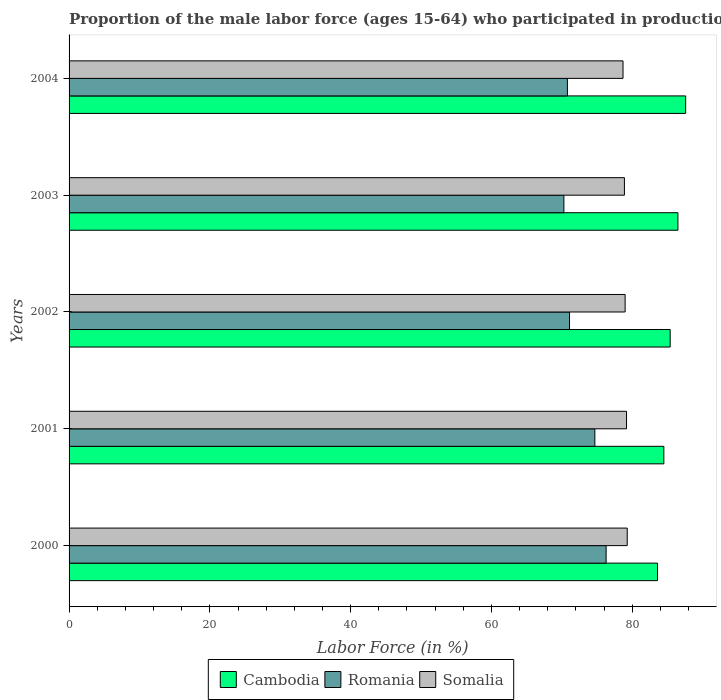How many different coloured bars are there?
Keep it short and to the point. 3. How many groups of bars are there?
Provide a succinct answer. 5. Are the number of bars per tick equal to the number of legend labels?
Ensure brevity in your answer.  Yes. Are the number of bars on each tick of the Y-axis equal?
Make the answer very short. Yes. How many bars are there on the 2nd tick from the top?
Keep it short and to the point. 3. How many bars are there on the 2nd tick from the bottom?
Offer a very short reply. 3. What is the label of the 1st group of bars from the top?
Provide a short and direct response. 2004. What is the proportion of the male labor force who participated in production in Romania in 2000?
Your response must be concise. 76.3. Across all years, what is the maximum proportion of the male labor force who participated in production in Cambodia?
Offer a terse response. 87.6. Across all years, what is the minimum proportion of the male labor force who participated in production in Romania?
Provide a short and direct response. 70.3. In which year was the proportion of the male labor force who participated in production in Somalia maximum?
Ensure brevity in your answer.  2000. In which year was the proportion of the male labor force who participated in production in Romania minimum?
Your answer should be compact. 2003. What is the total proportion of the male labor force who participated in production in Somalia in the graph?
Your answer should be very brief. 395.1. What is the difference between the proportion of the male labor force who participated in production in Romania in 2003 and that in 2004?
Offer a very short reply. -0.5. What is the difference between the proportion of the male labor force who participated in production in Somalia in 2000 and the proportion of the male labor force who participated in production in Cambodia in 2002?
Your answer should be compact. -6.1. What is the average proportion of the male labor force who participated in production in Romania per year?
Your answer should be very brief. 72.64. In the year 2003, what is the difference between the proportion of the male labor force who participated in production in Cambodia and proportion of the male labor force who participated in production in Somalia?
Your answer should be compact. 7.6. In how many years, is the proportion of the male labor force who participated in production in Romania greater than 60 %?
Make the answer very short. 5. What is the ratio of the proportion of the male labor force who participated in production in Cambodia in 2000 to that in 2002?
Provide a succinct answer. 0.98. Is the difference between the proportion of the male labor force who participated in production in Cambodia in 2002 and 2004 greater than the difference between the proportion of the male labor force who participated in production in Somalia in 2002 and 2004?
Your answer should be very brief. No. What is the difference between the highest and the second highest proportion of the male labor force who participated in production in Romania?
Offer a very short reply. 1.6. What is the difference between the highest and the lowest proportion of the male labor force who participated in production in Somalia?
Offer a very short reply. 0.6. Is the sum of the proportion of the male labor force who participated in production in Romania in 2000 and 2003 greater than the maximum proportion of the male labor force who participated in production in Somalia across all years?
Ensure brevity in your answer.  Yes. What does the 2nd bar from the top in 2002 represents?
Your answer should be compact. Romania. What does the 2nd bar from the bottom in 2003 represents?
Ensure brevity in your answer.  Romania. How many bars are there?
Offer a very short reply. 15. How many years are there in the graph?
Your response must be concise. 5. What is the difference between two consecutive major ticks on the X-axis?
Offer a very short reply. 20. Does the graph contain any zero values?
Provide a succinct answer. No. Does the graph contain grids?
Ensure brevity in your answer.  No. How are the legend labels stacked?
Your response must be concise. Horizontal. What is the title of the graph?
Your answer should be compact. Proportion of the male labor force (ages 15-64) who participated in production. Does "High income: OECD" appear as one of the legend labels in the graph?
Your answer should be very brief. No. What is the Labor Force (in %) of Cambodia in 2000?
Provide a succinct answer. 83.6. What is the Labor Force (in %) in Romania in 2000?
Make the answer very short. 76.3. What is the Labor Force (in %) of Somalia in 2000?
Ensure brevity in your answer.  79.3. What is the Labor Force (in %) of Cambodia in 2001?
Your response must be concise. 84.5. What is the Labor Force (in %) in Romania in 2001?
Your answer should be very brief. 74.7. What is the Labor Force (in %) in Somalia in 2001?
Offer a terse response. 79.2. What is the Labor Force (in %) in Cambodia in 2002?
Offer a terse response. 85.4. What is the Labor Force (in %) of Romania in 2002?
Give a very brief answer. 71.1. What is the Labor Force (in %) of Somalia in 2002?
Your answer should be compact. 79. What is the Labor Force (in %) in Cambodia in 2003?
Give a very brief answer. 86.5. What is the Labor Force (in %) in Romania in 2003?
Give a very brief answer. 70.3. What is the Labor Force (in %) in Somalia in 2003?
Your response must be concise. 78.9. What is the Labor Force (in %) in Cambodia in 2004?
Your answer should be compact. 87.6. What is the Labor Force (in %) in Romania in 2004?
Ensure brevity in your answer.  70.8. What is the Labor Force (in %) of Somalia in 2004?
Ensure brevity in your answer.  78.7. Across all years, what is the maximum Labor Force (in %) in Cambodia?
Provide a succinct answer. 87.6. Across all years, what is the maximum Labor Force (in %) of Romania?
Give a very brief answer. 76.3. Across all years, what is the maximum Labor Force (in %) in Somalia?
Offer a terse response. 79.3. Across all years, what is the minimum Labor Force (in %) in Cambodia?
Offer a very short reply. 83.6. Across all years, what is the minimum Labor Force (in %) of Romania?
Provide a short and direct response. 70.3. Across all years, what is the minimum Labor Force (in %) of Somalia?
Keep it short and to the point. 78.7. What is the total Labor Force (in %) in Cambodia in the graph?
Offer a very short reply. 427.6. What is the total Labor Force (in %) in Romania in the graph?
Provide a succinct answer. 363.2. What is the total Labor Force (in %) of Somalia in the graph?
Offer a terse response. 395.1. What is the difference between the Labor Force (in %) in Cambodia in 2000 and that in 2001?
Your answer should be very brief. -0.9. What is the difference between the Labor Force (in %) of Cambodia in 2000 and that in 2003?
Give a very brief answer. -2.9. What is the difference between the Labor Force (in %) of Romania in 2000 and that in 2003?
Ensure brevity in your answer.  6. What is the difference between the Labor Force (in %) in Somalia in 2000 and that in 2003?
Offer a terse response. 0.4. What is the difference between the Labor Force (in %) in Cambodia in 2000 and that in 2004?
Keep it short and to the point. -4. What is the difference between the Labor Force (in %) of Romania in 2000 and that in 2004?
Give a very brief answer. 5.5. What is the difference between the Labor Force (in %) in Somalia in 2000 and that in 2004?
Your answer should be very brief. 0.6. What is the difference between the Labor Force (in %) of Romania in 2001 and that in 2002?
Give a very brief answer. 3.6. What is the difference between the Labor Force (in %) in Romania in 2001 and that in 2003?
Your answer should be very brief. 4.4. What is the difference between the Labor Force (in %) of Cambodia in 2002 and that in 2003?
Your answer should be very brief. -1.1. What is the difference between the Labor Force (in %) in Somalia in 2002 and that in 2003?
Provide a succinct answer. 0.1. What is the difference between the Labor Force (in %) in Cambodia in 2002 and that in 2004?
Offer a terse response. -2.2. What is the difference between the Labor Force (in %) in Somalia in 2003 and that in 2004?
Offer a very short reply. 0.2. What is the difference between the Labor Force (in %) in Cambodia in 2000 and the Labor Force (in %) in Romania in 2001?
Offer a very short reply. 8.9. What is the difference between the Labor Force (in %) in Cambodia in 2000 and the Labor Force (in %) in Somalia in 2001?
Keep it short and to the point. 4.4. What is the difference between the Labor Force (in %) in Cambodia in 2000 and the Labor Force (in %) in Somalia in 2002?
Ensure brevity in your answer.  4.6. What is the difference between the Labor Force (in %) in Romania in 2000 and the Labor Force (in %) in Somalia in 2002?
Your answer should be very brief. -2.7. What is the difference between the Labor Force (in %) in Cambodia in 2000 and the Labor Force (in %) in Somalia in 2003?
Keep it short and to the point. 4.7. What is the difference between the Labor Force (in %) of Cambodia in 2000 and the Labor Force (in %) of Romania in 2004?
Your answer should be very brief. 12.8. What is the difference between the Labor Force (in %) of Romania in 2000 and the Labor Force (in %) of Somalia in 2004?
Your response must be concise. -2.4. What is the difference between the Labor Force (in %) of Cambodia in 2001 and the Labor Force (in %) of Somalia in 2002?
Your answer should be very brief. 5.5. What is the difference between the Labor Force (in %) of Cambodia in 2001 and the Labor Force (in %) of Romania in 2004?
Your answer should be very brief. 13.7. What is the difference between the Labor Force (in %) of Cambodia in 2001 and the Labor Force (in %) of Somalia in 2004?
Your response must be concise. 5.8. What is the difference between the Labor Force (in %) of Romania in 2001 and the Labor Force (in %) of Somalia in 2004?
Ensure brevity in your answer.  -4. What is the difference between the Labor Force (in %) of Cambodia in 2002 and the Labor Force (in %) of Romania in 2003?
Make the answer very short. 15.1. What is the difference between the Labor Force (in %) of Cambodia in 2002 and the Labor Force (in %) of Somalia in 2003?
Your answer should be very brief. 6.5. What is the difference between the Labor Force (in %) in Cambodia in 2002 and the Labor Force (in %) in Romania in 2004?
Your answer should be very brief. 14.6. What is the difference between the Labor Force (in %) of Cambodia in 2002 and the Labor Force (in %) of Somalia in 2004?
Provide a short and direct response. 6.7. What is the difference between the Labor Force (in %) in Romania in 2002 and the Labor Force (in %) in Somalia in 2004?
Offer a very short reply. -7.6. What is the difference between the Labor Force (in %) in Cambodia in 2003 and the Labor Force (in %) in Romania in 2004?
Provide a short and direct response. 15.7. What is the difference between the Labor Force (in %) in Cambodia in 2003 and the Labor Force (in %) in Somalia in 2004?
Provide a succinct answer. 7.8. What is the average Labor Force (in %) in Cambodia per year?
Your answer should be very brief. 85.52. What is the average Labor Force (in %) in Romania per year?
Make the answer very short. 72.64. What is the average Labor Force (in %) in Somalia per year?
Give a very brief answer. 79.02. In the year 2000, what is the difference between the Labor Force (in %) of Cambodia and Labor Force (in %) of Romania?
Your answer should be compact. 7.3. In the year 2000, what is the difference between the Labor Force (in %) of Cambodia and Labor Force (in %) of Somalia?
Offer a terse response. 4.3. In the year 2001, what is the difference between the Labor Force (in %) of Cambodia and Labor Force (in %) of Somalia?
Your answer should be compact. 5.3. In the year 2001, what is the difference between the Labor Force (in %) of Romania and Labor Force (in %) of Somalia?
Make the answer very short. -4.5. In the year 2002, what is the difference between the Labor Force (in %) of Cambodia and Labor Force (in %) of Romania?
Give a very brief answer. 14.3. In the year 2002, what is the difference between the Labor Force (in %) of Cambodia and Labor Force (in %) of Somalia?
Offer a terse response. 6.4. In the year 2002, what is the difference between the Labor Force (in %) in Romania and Labor Force (in %) in Somalia?
Keep it short and to the point. -7.9. In the year 2003, what is the difference between the Labor Force (in %) of Cambodia and Labor Force (in %) of Romania?
Your response must be concise. 16.2. In the year 2003, what is the difference between the Labor Force (in %) of Romania and Labor Force (in %) of Somalia?
Offer a terse response. -8.6. In the year 2004, what is the difference between the Labor Force (in %) of Cambodia and Labor Force (in %) of Romania?
Offer a terse response. 16.8. What is the ratio of the Labor Force (in %) of Cambodia in 2000 to that in 2001?
Ensure brevity in your answer.  0.99. What is the ratio of the Labor Force (in %) of Romania in 2000 to that in 2001?
Offer a terse response. 1.02. What is the ratio of the Labor Force (in %) in Somalia in 2000 to that in 2001?
Give a very brief answer. 1. What is the ratio of the Labor Force (in %) in Cambodia in 2000 to that in 2002?
Offer a terse response. 0.98. What is the ratio of the Labor Force (in %) in Romania in 2000 to that in 2002?
Your response must be concise. 1.07. What is the ratio of the Labor Force (in %) of Cambodia in 2000 to that in 2003?
Ensure brevity in your answer.  0.97. What is the ratio of the Labor Force (in %) of Romania in 2000 to that in 2003?
Provide a short and direct response. 1.09. What is the ratio of the Labor Force (in %) of Cambodia in 2000 to that in 2004?
Provide a succinct answer. 0.95. What is the ratio of the Labor Force (in %) of Romania in 2000 to that in 2004?
Offer a very short reply. 1.08. What is the ratio of the Labor Force (in %) of Somalia in 2000 to that in 2004?
Provide a succinct answer. 1.01. What is the ratio of the Labor Force (in %) in Cambodia in 2001 to that in 2002?
Ensure brevity in your answer.  0.99. What is the ratio of the Labor Force (in %) of Romania in 2001 to that in 2002?
Offer a terse response. 1.05. What is the ratio of the Labor Force (in %) of Somalia in 2001 to that in 2002?
Give a very brief answer. 1. What is the ratio of the Labor Force (in %) in Cambodia in 2001 to that in 2003?
Make the answer very short. 0.98. What is the ratio of the Labor Force (in %) of Romania in 2001 to that in 2003?
Offer a very short reply. 1.06. What is the ratio of the Labor Force (in %) of Somalia in 2001 to that in 2003?
Provide a succinct answer. 1. What is the ratio of the Labor Force (in %) of Cambodia in 2001 to that in 2004?
Provide a short and direct response. 0.96. What is the ratio of the Labor Force (in %) in Romania in 2001 to that in 2004?
Provide a short and direct response. 1.06. What is the ratio of the Labor Force (in %) of Somalia in 2001 to that in 2004?
Your response must be concise. 1.01. What is the ratio of the Labor Force (in %) of Cambodia in 2002 to that in 2003?
Ensure brevity in your answer.  0.99. What is the ratio of the Labor Force (in %) of Romania in 2002 to that in 2003?
Your answer should be compact. 1.01. What is the ratio of the Labor Force (in %) of Cambodia in 2002 to that in 2004?
Ensure brevity in your answer.  0.97. What is the ratio of the Labor Force (in %) of Romania in 2002 to that in 2004?
Provide a succinct answer. 1. What is the ratio of the Labor Force (in %) of Cambodia in 2003 to that in 2004?
Keep it short and to the point. 0.99. What is the ratio of the Labor Force (in %) of Somalia in 2003 to that in 2004?
Your answer should be compact. 1. What is the difference between the highest and the second highest Labor Force (in %) in Cambodia?
Keep it short and to the point. 1.1. What is the difference between the highest and the second highest Labor Force (in %) of Somalia?
Your answer should be compact. 0.1. 